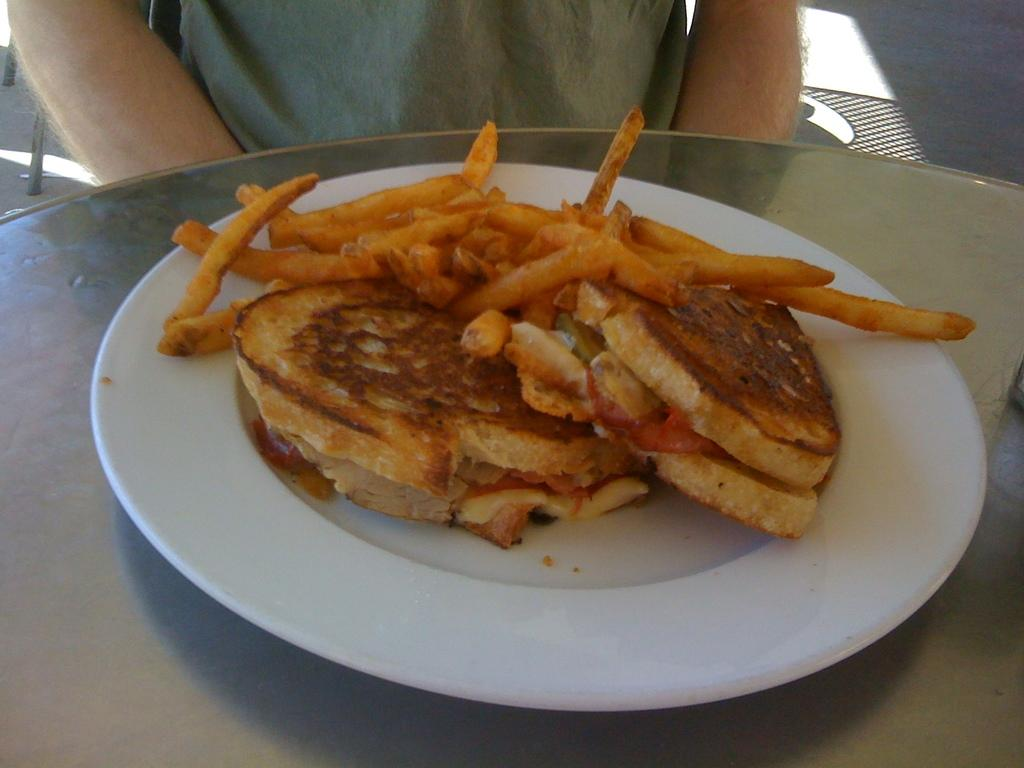What piece of furniture is present in the image? There is a table in the image. What is placed on the table? There is a plate on the table. What is on the plate? There are food items on the plate. Can you describe the person visible in the background of the image? Unfortunately, the facts provided do not give any details about the person in the background. What type of blood is visible on the pan in the image? There is no pan or blood present in the image. 